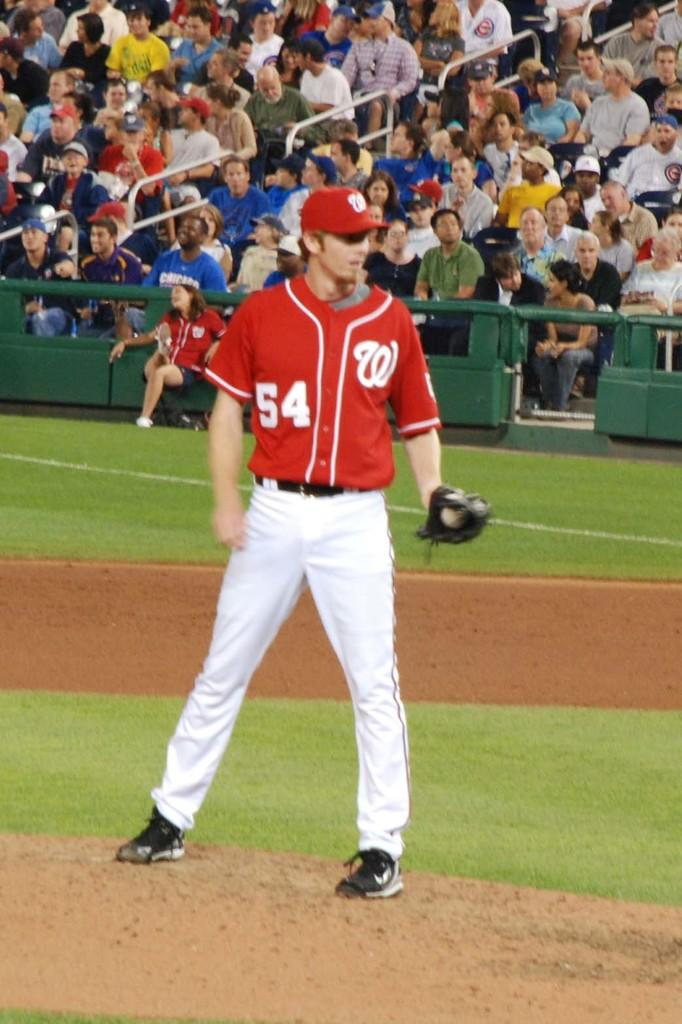<image>
Give a short and clear explanation of the subsequent image. a jersey with the letter W on it 